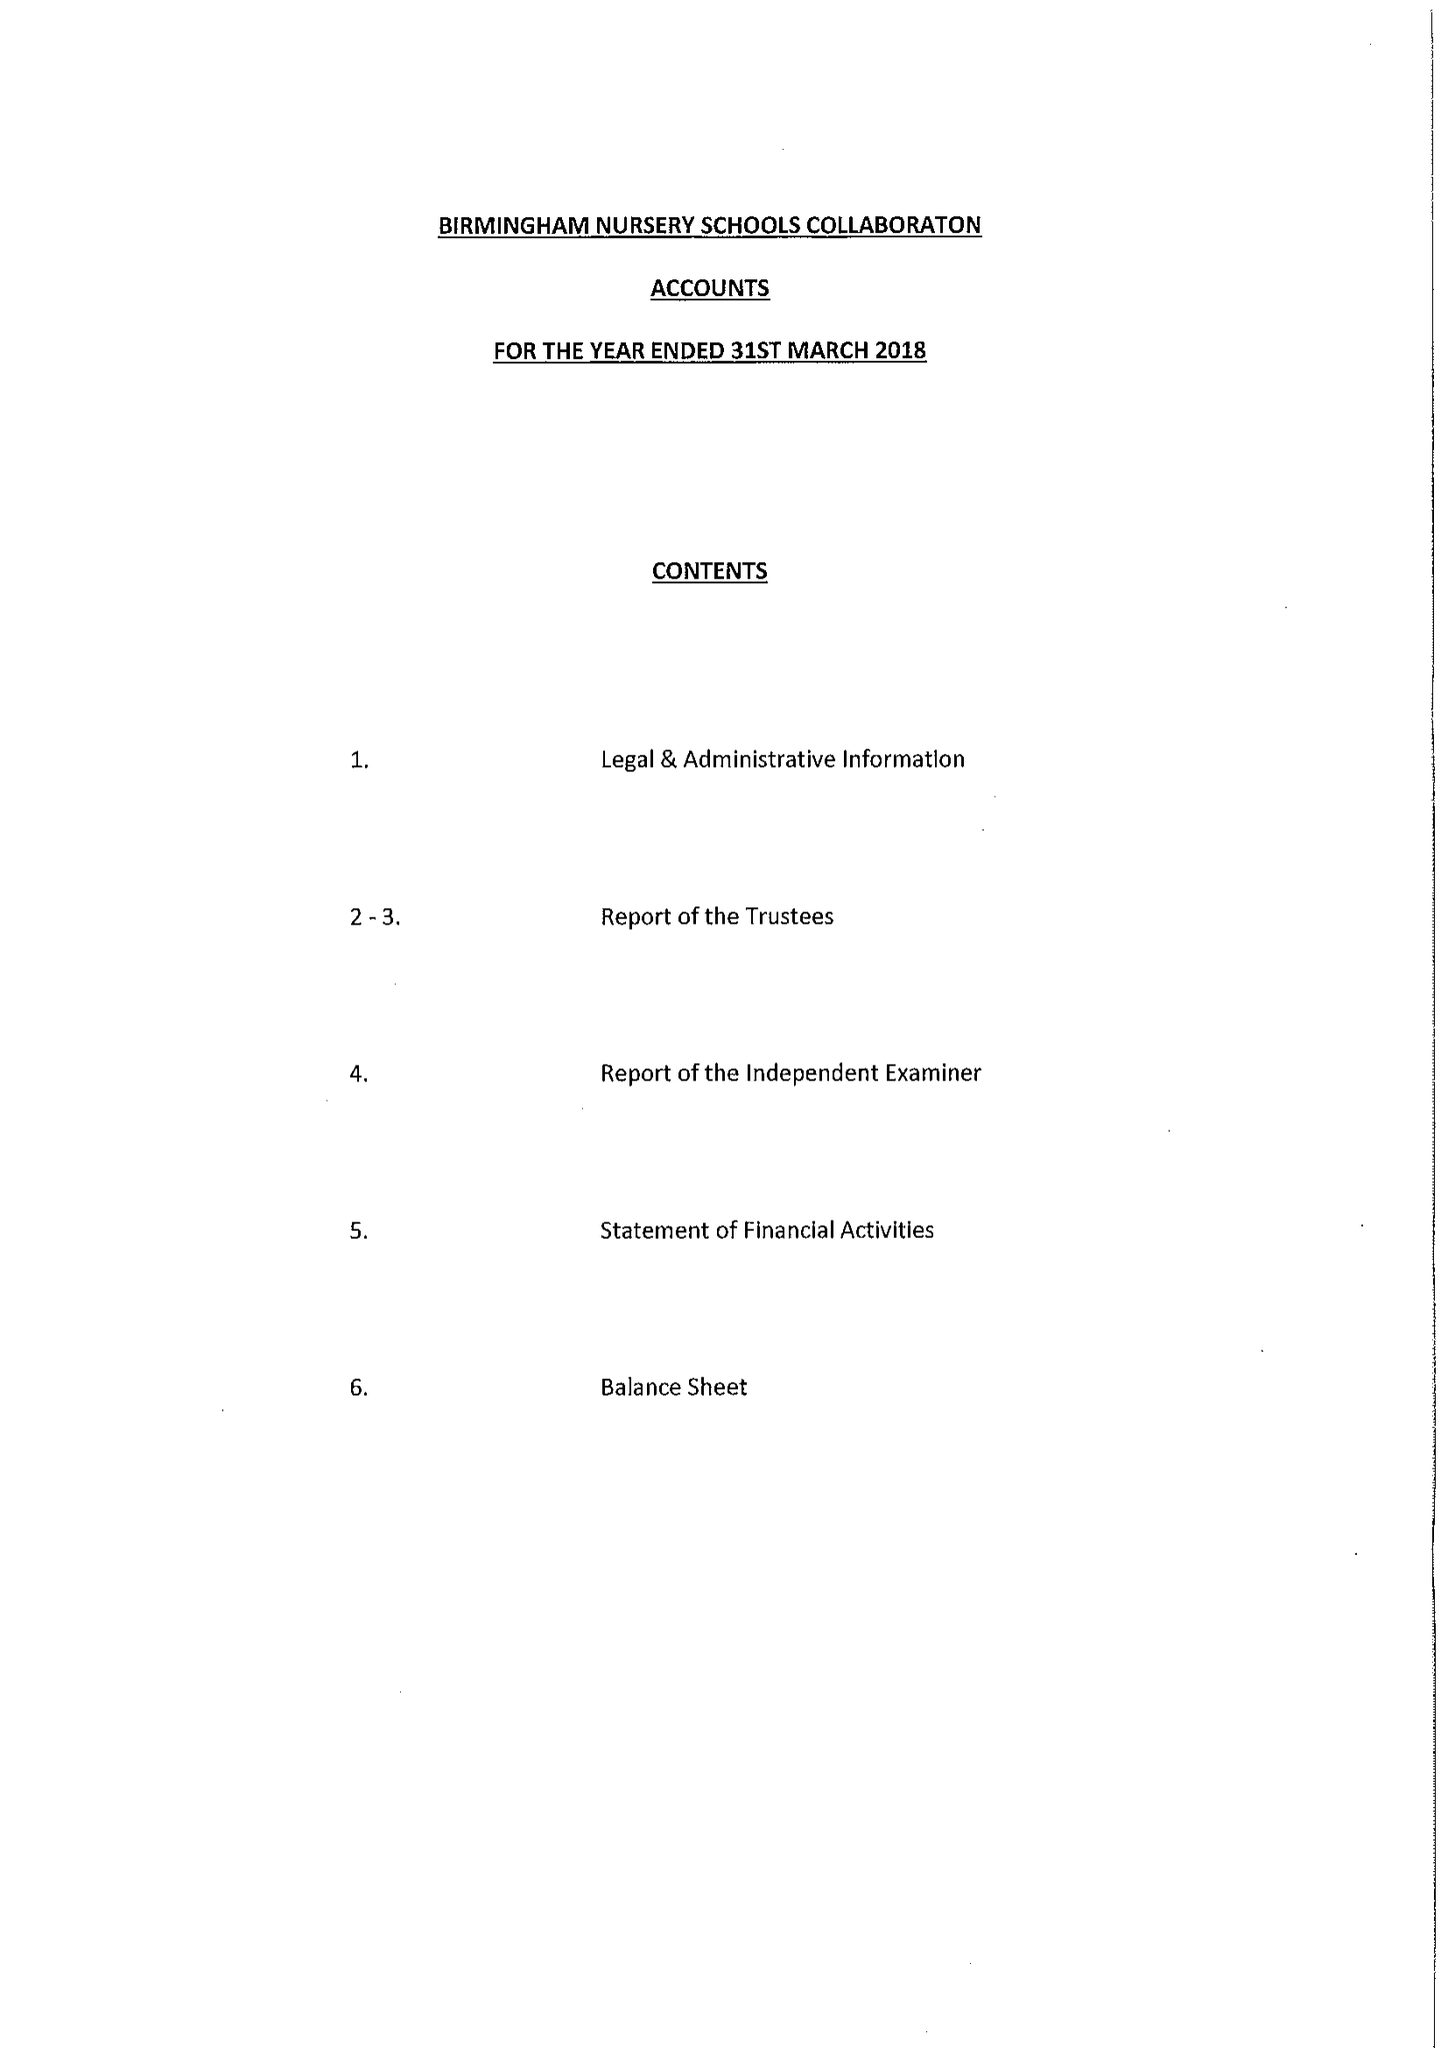What is the value for the spending_annually_in_british_pounds?
Answer the question using a single word or phrase. 66451.00 